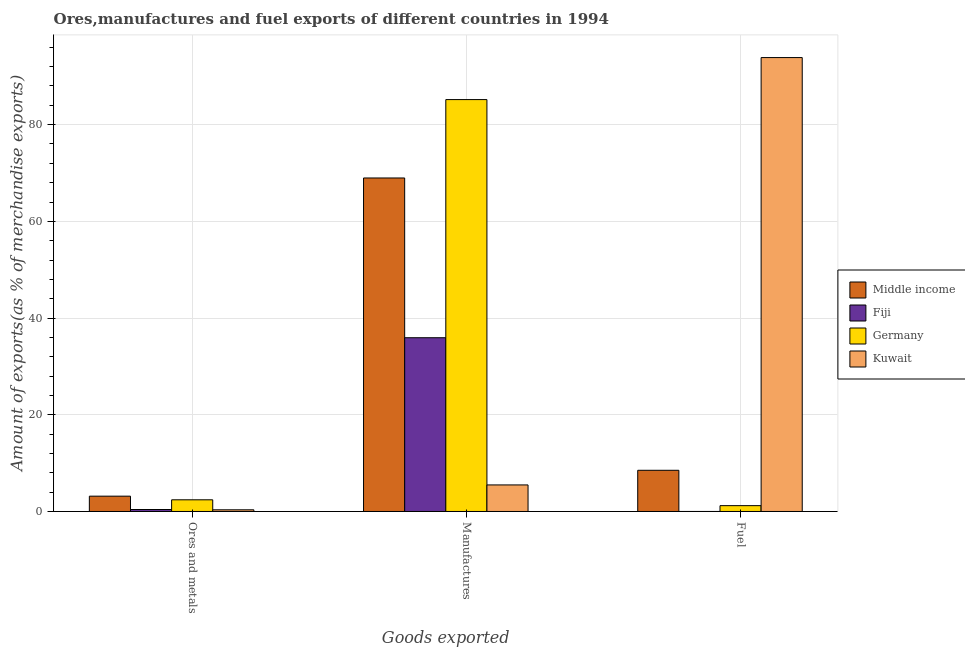How many different coloured bars are there?
Offer a very short reply. 4. Are the number of bars per tick equal to the number of legend labels?
Ensure brevity in your answer.  Yes. Are the number of bars on each tick of the X-axis equal?
Keep it short and to the point. Yes. How many bars are there on the 3rd tick from the left?
Your response must be concise. 4. How many bars are there on the 2nd tick from the right?
Provide a short and direct response. 4. What is the label of the 2nd group of bars from the left?
Provide a succinct answer. Manufactures. What is the percentage of ores and metals exports in Germany?
Offer a very short reply. 2.42. Across all countries, what is the maximum percentage of ores and metals exports?
Give a very brief answer. 3.17. Across all countries, what is the minimum percentage of ores and metals exports?
Give a very brief answer. 0.35. In which country was the percentage of manufactures exports maximum?
Give a very brief answer. Germany. In which country was the percentage of fuel exports minimum?
Offer a terse response. Fiji. What is the total percentage of ores and metals exports in the graph?
Provide a short and direct response. 6.34. What is the difference between the percentage of fuel exports in Germany and that in Kuwait?
Your answer should be compact. -92.66. What is the difference between the percentage of ores and metals exports in Kuwait and the percentage of manufactures exports in Fiji?
Offer a terse response. -35.59. What is the average percentage of manufactures exports per country?
Offer a very short reply. 48.89. What is the difference between the percentage of manufactures exports and percentage of ores and metals exports in Germany?
Provide a short and direct response. 82.76. In how many countries, is the percentage of fuel exports greater than 72 %?
Your answer should be compact. 1. What is the ratio of the percentage of ores and metals exports in Fiji to that in Middle income?
Your response must be concise. 0.13. What is the difference between the highest and the second highest percentage of ores and metals exports?
Offer a terse response. 0.75. What is the difference between the highest and the lowest percentage of manufactures exports?
Make the answer very short. 79.69. Is the sum of the percentage of fuel exports in Germany and Middle income greater than the maximum percentage of ores and metals exports across all countries?
Your response must be concise. Yes. What does the 4th bar from the right in Manufactures represents?
Offer a very short reply. Middle income. Is it the case that in every country, the sum of the percentage of ores and metals exports and percentage of manufactures exports is greater than the percentage of fuel exports?
Keep it short and to the point. No. Are all the bars in the graph horizontal?
Give a very brief answer. No. How many countries are there in the graph?
Keep it short and to the point. 4. Does the graph contain any zero values?
Your answer should be very brief. No. How many legend labels are there?
Make the answer very short. 4. How are the legend labels stacked?
Offer a terse response. Vertical. What is the title of the graph?
Provide a short and direct response. Ores,manufactures and fuel exports of different countries in 1994. What is the label or title of the X-axis?
Give a very brief answer. Goods exported. What is the label or title of the Y-axis?
Offer a very short reply. Amount of exports(as % of merchandise exports). What is the Amount of exports(as % of merchandise exports) in Middle income in Ores and metals?
Offer a very short reply. 3.17. What is the Amount of exports(as % of merchandise exports) of Fiji in Ores and metals?
Offer a very short reply. 0.41. What is the Amount of exports(as % of merchandise exports) of Germany in Ores and metals?
Offer a terse response. 2.42. What is the Amount of exports(as % of merchandise exports) of Kuwait in Ores and metals?
Make the answer very short. 0.35. What is the Amount of exports(as % of merchandise exports) in Middle income in Manufactures?
Offer a very short reply. 68.97. What is the Amount of exports(as % of merchandise exports) in Fiji in Manufactures?
Ensure brevity in your answer.  35.93. What is the Amount of exports(as % of merchandise exports) in Germany in Manufactures?
Make the answer very short. 85.18. What is the Amount of exports(as % of merchandise exports) in Kuwait in Manufactures?
Make the answer very short. 5.49. What is the Amount of exports(as % of merchandise exports) in Middle income in Fuel?
Provide a succinct answer. 8.52. What is the Amount of exports(as % of merchandise exports) of Fiji in Fuel?
Make the answer very short. 0. What is the Amount of exports(as % of merchandise exports) in Germany in Fuel?
Keep it short and to the point. 1.21. What is the Amount of exports(as % of merchandise exports) of Kuwait in Fuel?
Give a very brief answer. 93.87. Across all Goods exported, what is the maximum Amount of exports(as % of merchandise exports) of Middle income?
Provide a succinct answer. 68.97. Across all Goods exported, what is the maximum Amount of exports(as % of merchandise exports) in Fiji?
Provide a succinct answer. 35.93. Across all Goods exported, what is the maximum Amount of exports(as % of merchandise exports) of Germany?
Make the answer very short. 85.18. Across all Goods exported, what is the maximum Amount of exports(as % of merchandise exports) in Kuwait?
Ensure brevity in your answer.  93.87. Across all Goods exported, what is the minimum Amount of exports(as % of merchandise exports) of Middle income?
Provide a succinct answer. 3.17. Across all Goods exported, what is the minimum Amount of exports(as % of merchandise exports) of Fiji?
Ensure brevity in your answer.  0. Across all Goods exported, what is the minimum Amount of exports(as % of merchandise exports) in Germany?
Give a very brief answer. 1.21. Across all Goods exported, what is the minimum Amount of exports(as % of merchandise exports) of Kuwait?
Ensure brevity in your answer.  0.35. What is the total Amount of exports(as % of merchandise exports) of Middle income in the graph?
Your response must be concise. 80.66. What is the total Amount of exports(as % of merchandise exports) in Fiji in the graph?
Your answer should be very brief. 36.34. What is the total Amount of exports(as % of merchandise exports) in Germany in the graph?
Your answer should be very brief. 88.8. What is the total Amount of exports(as % of merchandise exports) in Kuwait in the graph?
Your answer should be very brief. 99.71. What is the difference between the Amount of exports(as % of merchandise exports) in Middle income in Ores and metals and that in Manufactures?
Keep it short and to the point. -65.8. What is the difference between the Amount of exports(as % of merchandise exports) in Fiji in Ores and metals and that in Manufactures?
Give a very brief answer. -35.52. What is the difference between the Amount of exports(as % of merchandise exports) in Germany in Ores and metals and that in Manufactures?
Ensure brevity in your answer.  -82.76. What is the difference between the Amount of exports(as % of merchandise exports) of Kuwait in Ores and metals and that in Manufactures?
Keep it short and to the point. -5.15. What is the difference between the Amount of exports(as % of merchandise exports) in Middle income in Ores and metals and that in Fuel?
Your answer should be compact. -5.35. What is the difference between the Amount of exports(as % of merchandise exports) of Fiji in Ores and metals and that in Fuel?
Make the answer very short. 0.41. What is the difference between the Amount of exports(as % of merchandise exports) in Germany in Ores and metals and that in Fuel?
Provide a short and direct response. 1.21. What is the difference between the Amount of exports(as % of merchandise exports) of Kuwait in Ores and metals and that in Fuel?
Keep it short and to the point. -93.52. What is the difference between the Amount of exports(as % of merchandise exports) in Middle income in Manufactures and that in Fuel?
Give a very brief answer. 60.45. What is the difference between the Amount of exports(as % of merchandise exports) of Fiji in Manufactures and that in Fuel?
Your answer should be compact. 35.93. What is the difference between the Amount of exports(as % of merchandise exports) of Germany in Manufactures and that in Fuel?
Give a very brief answer. 83.97. What is the difference between the Amount of exports(as % of merchandise exports) in Kuwait in Manufactures and that in Fuel?
Make the answer very short. -88.38. What is the difference between the Amount of exports(as % of merchandise exports) of Middle income in Ores and metals and the Amount of exports(as % of merchandise exports) of Fiji in Manufactures?
Give a very brief answer. -32.76. What is the difference between the Amount of exports(as % of merchandise exports) in Middle income in Ores and metals and the Amount of exports(as % of merchandise exports) in Germany in Manufactures?
Your answer should be very brief. -82.01. What is the difference between the Amount of exports(as % of merchandise exports) in Middle income in Ores and metals and the Amount of exports(as % of merchandise exports) in Kuwait in Manufactures?
Make the answer very short. -2.32. What is the difference between the Amount of exports(as % of merchandise exports) of Fiji in Ores and metals and the Amount of exports(as % of merchandise exports) of Germany in Manufactures?
Make the answer very short. -84.77. What is the difference between the Amount of exports(as % of merchandise exports) of Fiji in Ores and metals and the Amount of exports(as % of merchandise exports) of Kuwait in Manufactures?
Your answer should be compact. -5.08. What is the difference between the Amount of exports(as % of merchandise exports) of Germany in Ores and metals and the Amount of exports(as % of merchandise exports) of Kuwait in Manufactures?
Provide a succinct answer. -3.08. What is the difference between the Amount of exports(as % of merchandise exports) of Middle income in Ores and metals and the Amount of exports(as % of merchandise exports) of Fiji in Fuel?
Offer a very short reply. 3.17. What is the difference between the Amount of exports(as % of merchandise exports) in Middle income in Ores and metals and the Amount of exports(as % of merchandise exports) in Germany in Fuel?
Your response must be concise. 1.96. What is the difference between the Amount of exports(as % of merchandise exports) in Middle income in Ores and metals and the Amount of exports(as % of merchandise exports) in Kuwait in Fuel?
Your answer should be compact. -90.7. What is the difference between the Amount of exports(as % of merchandise exports) in Fiji in Ores and metals and the Amount of exports(as % of merchandise exports) in Germany in Fuel?
Your answer should be compact. -0.8. What is the difference between the Amount of exports(as % of merchandise exports) in Fiji in Ores and metals and the Amount of exports(as % of merchandise exports) in Kuwait in Fuel?
Ensure brevity in your answer.  -93.46. What is the difference between the Amount of exports(as % of merchandise exports) in Germany in Ores and metals and the Amount of exports(as % of merchandise exports) in Kuwait in Fuel?
Keep it short and to the point. -91.45. What is the difference between the Amount of exports(as % of merchandise exports) of Middle income in Manufactures and the Amount of exports(as % of merchandise exports) of Fiji in Fuel?
Your answer should be compact. 68.97. What is the difference between the Amount of exports(as % of merchandise exports) in Middle income in Manufactures and the Amount of exports(as % of merchandise exports) in Germany in Fuel?
Your response must be concise. 67.76. What is the difference between the Amount of exports(as % of merchandise exports) of Middle income in Manufactures and the Amount of exports(as % of merchandise exports) of Kuwait in Fuel?
Offer a terse response. -24.9. What is the difference between the Amount of exports(as % of merchandise exports) in Fiji in Manufactures and the Amount of exports(as % of merchandise exports) in Germany in Fuel?
Provide a succinct answer. 34.73. What is the difference between the Amount of exports(as % of merchandise exports) in Fiji in Manufactures and the Amount of exports(as % of merchandise exports) in Kuwait in Fuel?
Offer a very short reply. -57.94. What is the difference between the Amount of exports(as % of merchandise exports) in Germany in Manufactures and the Amount of exports(as % of merchandise exports) in Kuwait in Fuel?
Keep it short and to the point. -8.69. What is the average Amount of exports(as % of merchandise exports) of Middle income per Goods exported?
Ensure brevity in your answer.  26.89. What is the average Amount of exports(as % of merchandise exports) in Fiji per Goods exported?
Your answer should be compact. 12.11. What is the average Amount of exports(as % of merchandise exports) of Germany per Goods exported?
Provide a short and direct response. 29.6. What is the average Amount of exports(as % of merchandise exports) of Kuwait per Goods exported?
Provide a succinct answer. 33.24. What is the difference between the Amount of exports(as % of merchandise exports) in Middle income and Amount of exports(as % of merchandise exports) in Fiji in Ores and metals?
Your answer should be compact. 2.76. What is the difference between the Amount of exports(as % of merchandise exports) in Middle income and Amount of exports(as % of merchandise exports) in Germany in Ores and metals?
Provide a succinct answer. 0.75. What is the difference between the Amount of exports(as % of merchandise exports) of Middle income and Amount of exports(as % of merchandise exports) of Kuwait in Ores and metals?
Offer a terse response. 2.82. What is the difference between the Amount of exports(as % of merchandise exports) of Fiji and Amount of exports(as % of merchandise exports) of Germany in Ores and metals?
Provide a succinct answer. -2.01. What is the difference between the Amount of exports(as % of merchandise exports) in Fiji and Amount of exports(as % of merchandise exports) in Kuwait in Ores and metals?
Provide a short and direct response. 0.06. What is the difference between the Amount of exports(as % of merchandise exports) in Germany and Amount of exports(as % of merchandise exports) in Kuwait in Ores and metals?
Provide a succinct answer. 2.07. What is the difference between the Amount of exports(as % of merchandise exports) in Middle income and Amount of exports(as % of merchandise exports) in Fiji in Manufactures?
Keep it short and to the point. 33.04. What is the difference between the Amount of exports(as % of merchandise exports) of Middle income and Amount of exports(as % of merchandise exports) of Germany in Manufactures?
Give a very brief answer. -16.21. What is the difference between the Amount of exports(as % of merchandise exports) in Middle income and Amount of exports(as % of merchandise exports) in Kuwait in Manufactures?
Give a very brief answer. 63.48. What is the difference between the Amount of exports(as % of merchandise exports) of Fiji and Amount of exports(as % of merchandise exports) of Germany in Manufactures?
Your answer should be compact. -49.25. What is the difference between the Amount of exports(as % of merchandise exports) of Fiji and Amount of exports(as % of merchandise exports) of Kuwait in Manufactures?
Provide a succinct answer. 30.44. What is the difference between the Amount of exports(as % of merchandise exports) of Germany and Amount of exports(as % of merchandise exports) of Kuwait in Manufactures?
Offer a very short reply. 79.69. What is the difference between the Amount of exports(as % of merchandise exports) in Middle income and Amount of exports(as % of merchandise exports) in Fiji in Fuel?
Give a very brief answer. 8.52. What is the difference between the Amount of exports(as % of merchandise exports) in Middle income and Amount of exports(as % of merchandise exports) in Germany in Fuel?
Your response must be concise. 7.31. What is the difference between the Amount of exports(as % of merchandise exports) in Middle income and Amount of exports(as % of merchandise exports) in Kuwait in Fuel?
Give a very brief answer. -85.35. What is the difference between the Amount of exports(as % of merchandise exports) of Fiji and Amount of exports(as % of merchandise exports) of Germany in Fuel?
Ensure brevity in your answer.  -1.21. What is the difference between the Amount of exports(as % of merchandise exports) of Fiji and Amount of exports(as % of merchandise exports) of Kuwait in Fuel?
Provide a short and direct response. -93.87. What is the difference between the Amount of exports(as % of merchandise exports) in Germany and Amount of exports(as % of merchandise exports) in Kuwait in Fuel?
Give a very brief answer. -92.66. What is the ratio of the Amount of exports(as % of merchandise exports) in Middle income in Ores and metals to that in Manufactures?
Give a very brief answer. 0.05. What is the ratio of the Amount of exports(as % of merchandise exports) of Fiji in Ores and metals to that in Manufactures?
Provide a short and direct response. 0.01. What is the ratio of the Amount of exports(as % of merchandise exports) in Germany in Ores and metals to that in Manufactures?
Make the answer very short. 0.03. What is the ratio of the Amount of exports(as % of merchandise exports) in Kuwait in Ores and metals to that in Manufactures?
Make the answer very short. 0.06. What is the ratio of the Amount of exports(as % of merchandise exports) in Middle income in Ores and metals to that in Fuel?
Your answer should be very brief. 0.37. What is the ratio of the Amount of exports(as % of merchandise exports) in Fiji in Ores and metals to that in Fuel?
Offer a very short reply. 304.83. What is the ratio of the Amount of exports(as % of merchandise exports) of Germany in Ores and metals to that in Fuel?
Offer a very short reply. 2. What is the ratio of the Amount of exports(as % of merchandise exports) of Kuwait in Ores and metals to that in Fuel?
Offer a terse response. 0. What is the ratio of the Amount of exports(as % of merchandise exports) of Middle income in Manufactures to that in Fuel?
Keep it short and to the point. 8.09. What is the ratio of the Amount of exports(as % of merchandise exports) of Fiji in Manufactures to that in Fuel?
Make the answer very short. 2.68e+04. What is the ratio of the Amount of exports(as % of merchandise exports) of Germany in Manufactures to that in Fuel?
Your response must be concise. 70.6. What is the ratio of the Amount of exports(as % of merchandise exports) in Kuwait in Manufactures to that in Fuel?
Offer a very short reply. 0.06. What is the difference between the highest and the second highest Amount of exports(as % of merchandise exports) of Middle income?
Your response must be concise. 60.45. What is the difference between the highest and the second highest Amount of exports(as % of merchandise exports) of Fiji?
Ensure brevity in your answer.  35.52. What is the difference between the highest and the second highest Amount of exports(as % of merchandise exports) in Germany?
Your answer should be very brief. 82.76. What is the difference between the highest and the second highest Amount of exports(as % of merchandise exports) of Kuwait?
Provide a short and direct response. 88.38. What is the difference between the highest and the lowest Amount of exports(as % of merchandise exports) of Middle income?
Offer a terse response. 65.8. What is the difference between the highest and the lowest Amount of exports(as % of merchandise exports) of Fiji?
Your answer should be compact. 35.93. What is the difference between the highest and the lowest Amount of exports(as % of merchandise exports) in Germany?
Your answer should be very brief. 83.97. What is the difference between the highest and the lowest Amount of exports(as % of merchandise exports) of Kuwait?
Your answer should be very brief. 93.52. 